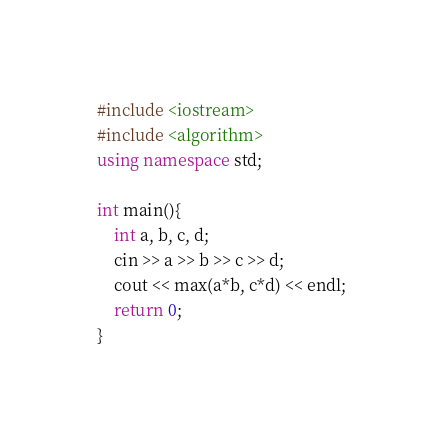<code> <loc_0><loc_0><loc_500><loc_500><_C++_>#include <iostream>
#include <algorithm>
using namespace std;

int main(){
    int a, b, c, d;
    cin >> a >> b >> c >> d;
    cout << max(a*b, c*d) << endl;
    return 0;
}</code> 